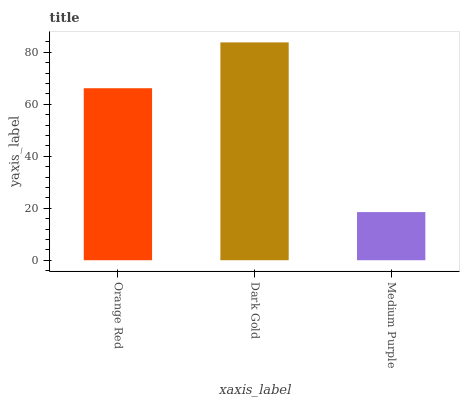Is Dark Gold the minimum?
Answer yes or no. No. Is Medium Purple the maximum?
Answer yes or no. No. Is Dark Gold greater than Medium Purple?
Answer yes or no. Yes. Is Medium Purple less than Dark Gold?
Answer yes or no. Yes. Is Medium Purple greater than Dark Gold?
Answer yes or no. No. Is Dark Gold less than Medium Purple?
Answer yes or no. No. Is Orange Red the high median?
Answer yes or no. Yes. Is Orange Red the low median?
Answer yes or no. Yes. Is Medium Purple the high median?
Answer yes or no. No. Is Dark Gold the low median?
Answer yes or no. No. 